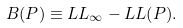Convert formula to latex. <formula><loc_0><loc_0><loc_500><loc_500>B ( P ) \equiv \L L L _ { \infty } - \L L L ( P ) .</formula> 